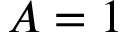Convert formula to latex. <formula><loc_0><loc_0><loc_500><loc_500>A = 1</formula> 